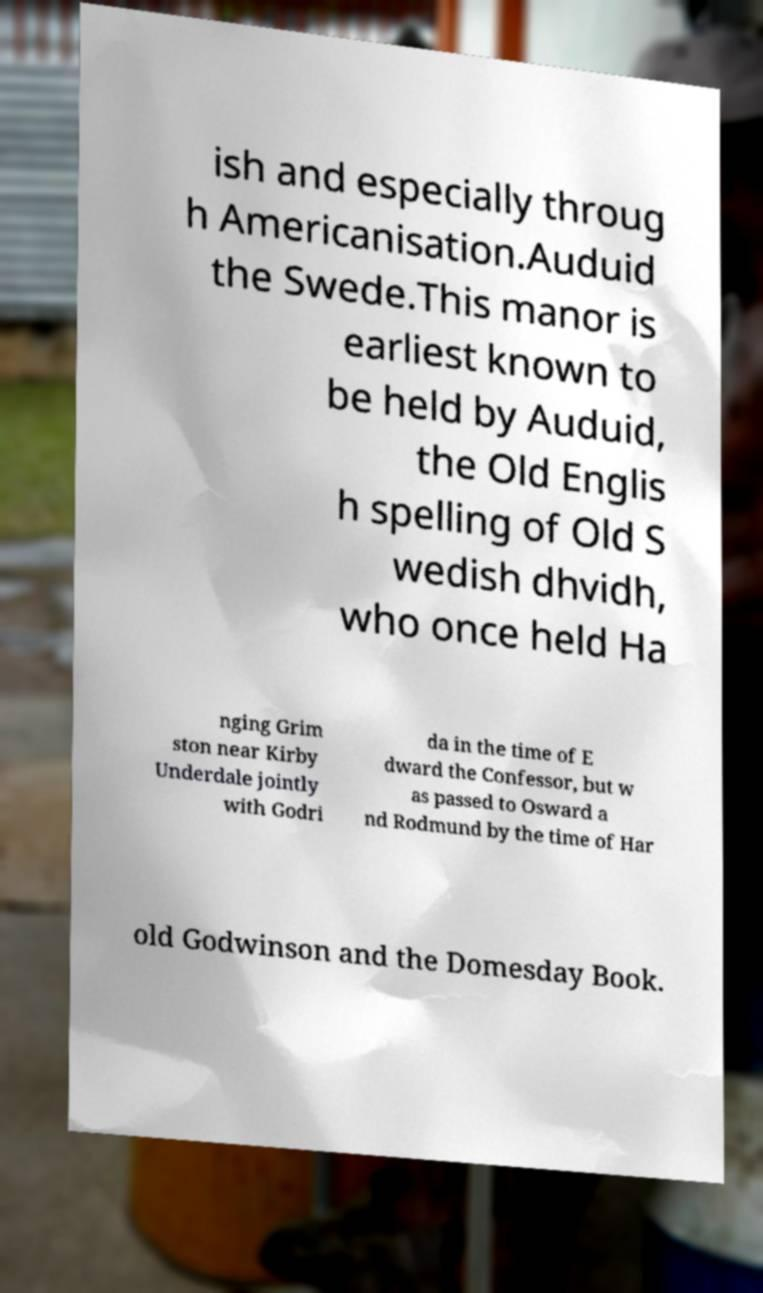Can you accurately transcribe the text from the provided image for me? ish and especially throug h Americanisation.Auduid the Swede.This manor is earliest known to be held by Auduid, the Old Englis h spelling of Old S wedish dhvidh, who once held Ha nging Grim ston near Kirby Underdale jointly with Godri da in the time of E dward the Confessor, but w as passed to Osward a nd Rodmund by the time of Har old Godwinson and the Domesday Book. 